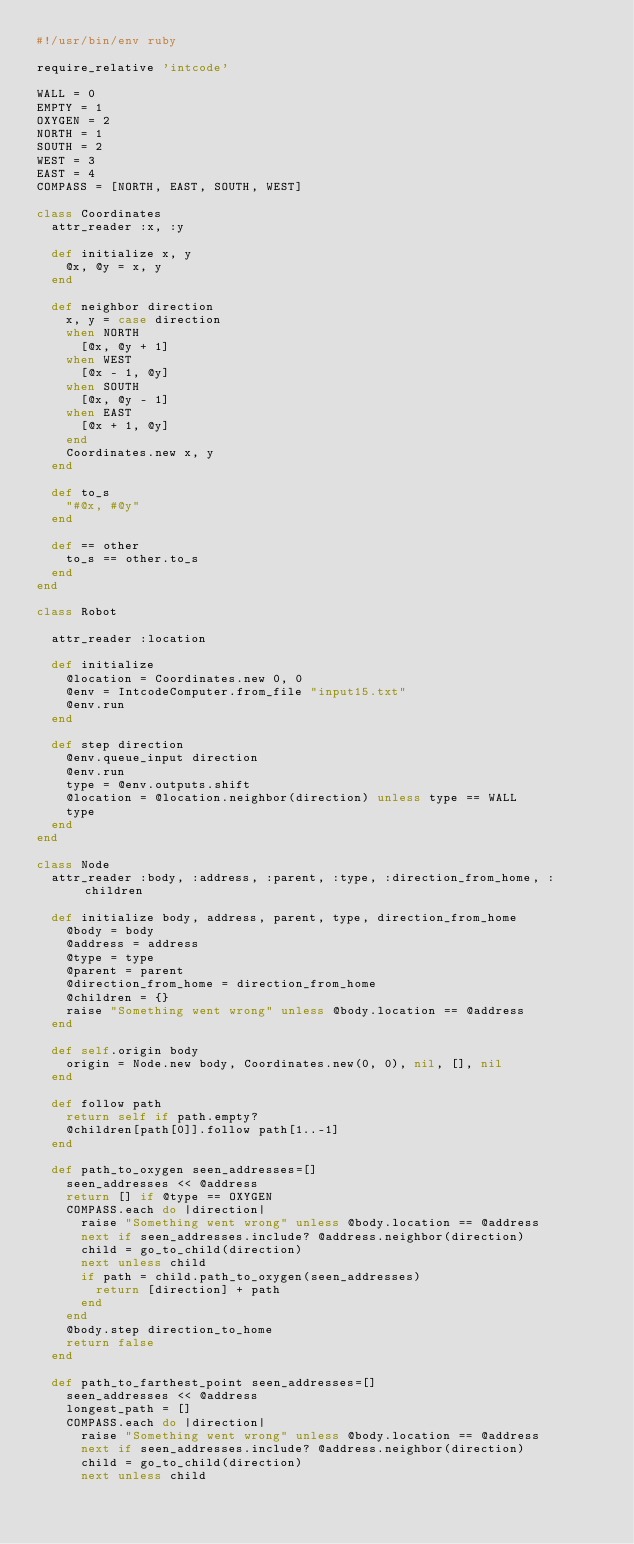Convert code to text. <code><loc_0><loc_0><loc_500><loc_500><_Ruby_>#!/usr/bin/env ruby

require_relative 'intcode'

WALL = 0
EMPTY = 1
OXYGEN = 2
NORTH = 1
SOUTH = 2
WEST = 3
EAST = 4
COMPASS = [NORTH, EAST, SOUTH, WEST]

class Coordinates
  attr_reader :x, :y

  def initialize x, y
    @x, @y = x, y
  end

  def neighbor direction
    x, y = case direction
    when NORTH
      [@x, @y + 1]
    when WEST
      [@x - 1, @y]
    when SOUTH
      [@x, @y - 1]
    when EAST
      [@x + 1, @y]
    end
    Coordinates.new x, y
  end

  def to_s
    "#@x, #@y"
  end

  def == other
    to_s == other.to_s
  end
end

class Robot

  attr_reader :location

  def initialize
    @location = Coordinates.new 0, 0
    @env = IntcodeComputer.from_file "input15.txt"
    @env.run
  end

  def step direction
    @env.queue_input direction
    @env.run
    type = @env.outputs.shift
    @location = @location.neighbor(direction) unless type == WALL
    type
  end
end

class Node
  attr_reader :body, :address, :parent, :type, :direction_from_home, :children

  def initialize body, address, parent, type, direction_from_home
    @body = body
    @address = address
    @type = type
    @parent = parent
    @direction_from_home = direction_from_home
    @children = {}
    raise "Something went wrong" unless @body.location == @address
  end

  def self.origin body
    origin = Node.new body, Coordinates.new(0, 0), nil, [], nil
  end

  def follow path
    return self if path.empty?
    @children[path[0]].follow path[1..-1]
  end

  def path_to_oxygen seen_addresses=[]
    seen_addresses << @address
    return [] if @type == OXYGEN
    COMPASS.each do |direction|
      raise "Something went wrong" unless @body.location == @address
      next if seen_addresses.include? @address.neighbor(direction)
      child = go_to_child(direction)
      next unless child
      if path = child.path_to_oxygen(seen_addresses)
        return [direction] + path
      end
    end
    @body.step direction_to_home
    return false
  end

  def path_to_farthest_point seen_addresses=[]
    seen_addresses << @address
    longest_path = []
    COMPASS.each do |direction|
      raise "Something went wrong" unless @body.location == @address
      next if seen_addresses.include? @address.neighbor(direction)
      child = go_to_child(direction)
      next unless child</code> 